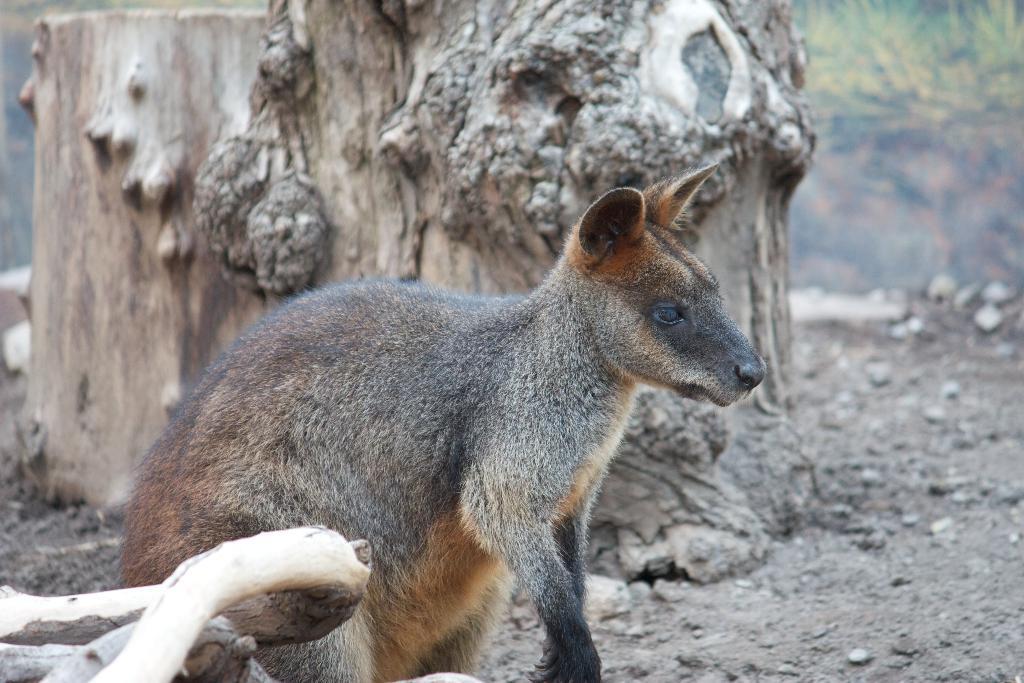How would you summarize this image in a sentence or two? This is outdoor picture. In this picture we can see an animal named wallaby. we can see a wide branch. Here we can see pebbles and few stones and sand. On the background of the picture we cannot see anything because it's blur. 